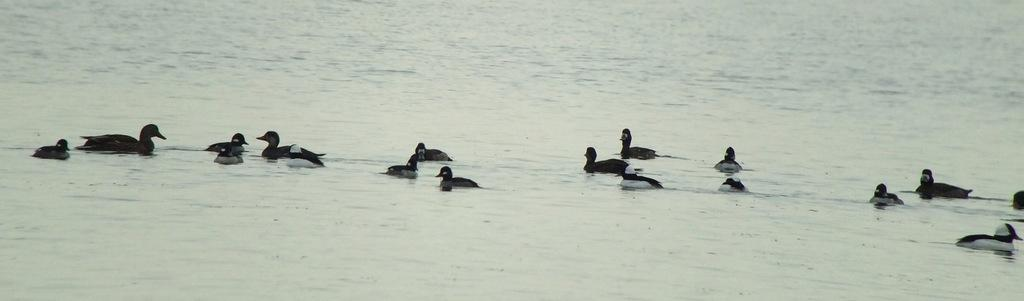What type of animals can be seen in the image? There are ducks in the image. Where are the ducks located? The ducks are on the water. What type of ice can be seen on the ducks' wings in the image? There is no ice present on the ducks' wings in the image. What curve can be seen in the image? There is no curve mentioned or visible in the image; it only features ducks on the water. 